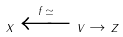Convert formula to latex. <formula><loc_0><loc_0><loc_500><loc_500>x \xleftarrow { f \, \simeq } v \to z</formula> 